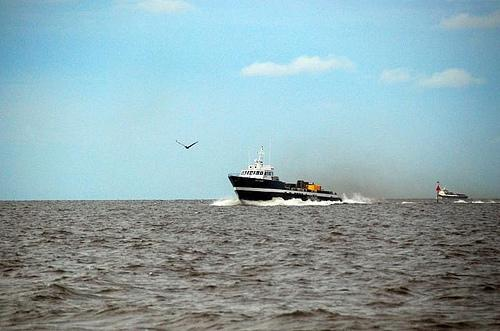What is the boat plowing through? Please explain your reasoning. ocean. The boat is on a large mass of water with no land in sight. 